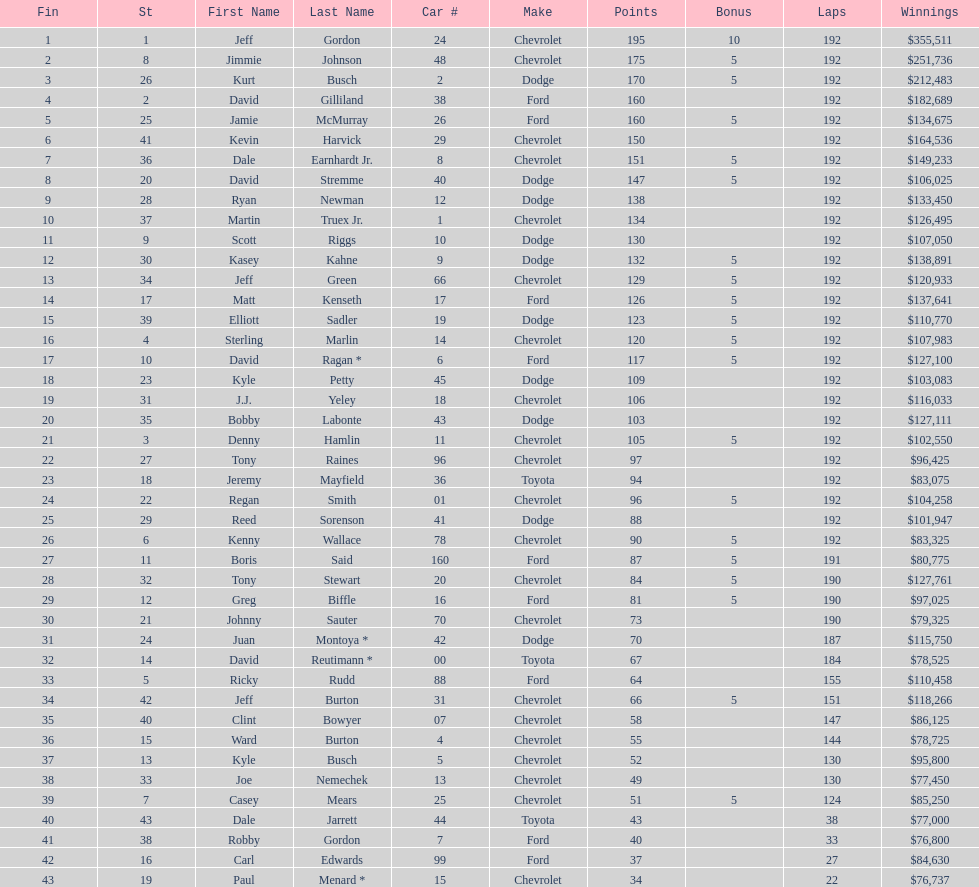Who is first in number of winnings on this list? Jeff Gordon. 